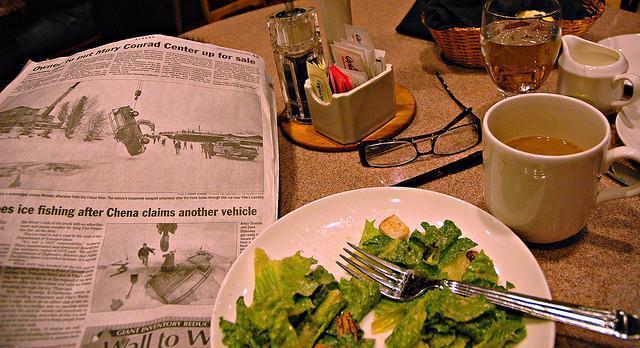How many forks are visible?
Give a very brief answer. 1. How many cups are there?
Give a very brief answer. 2. How many people are sitting in kayaks?
Give a very brief answer. 0. 